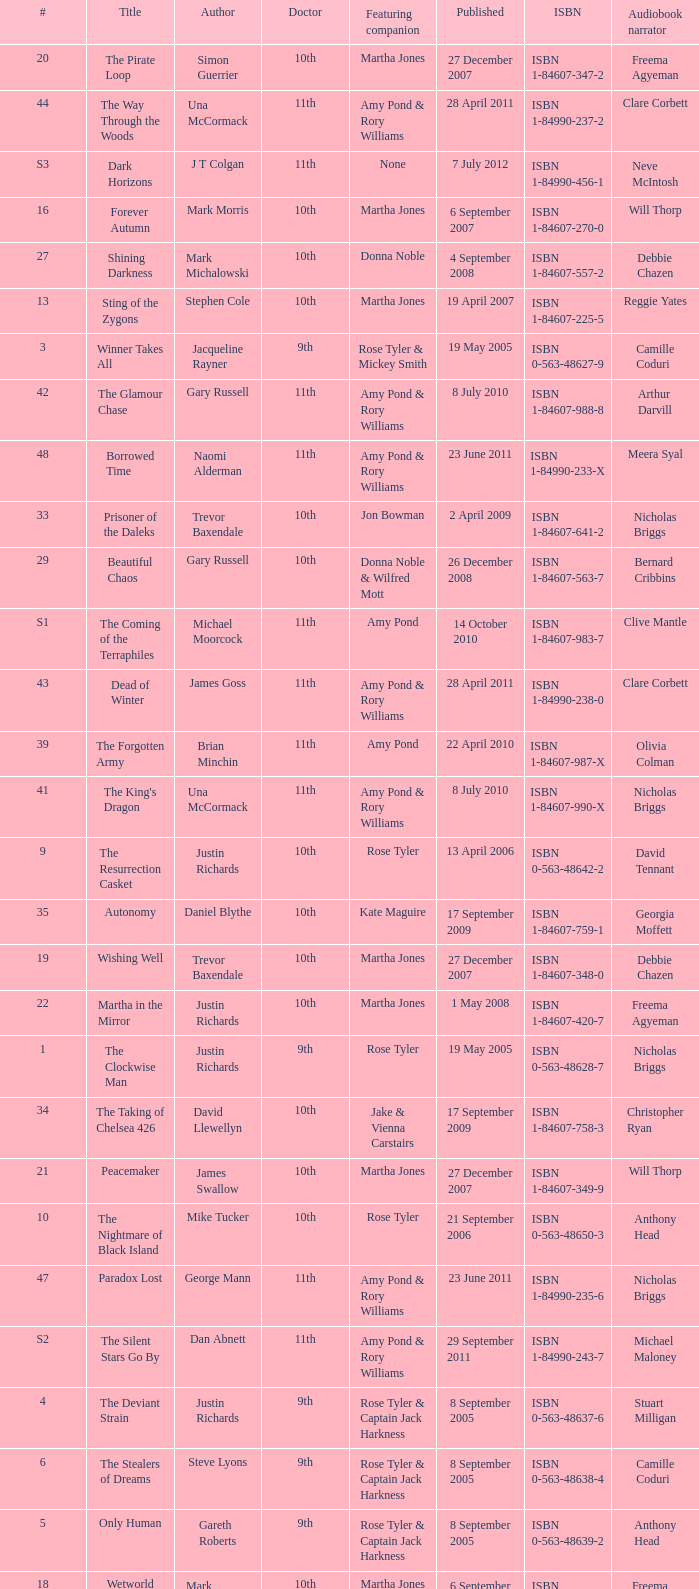What is the publication date of the book that is narrated by Michael Maloney? 29 September 2011. 